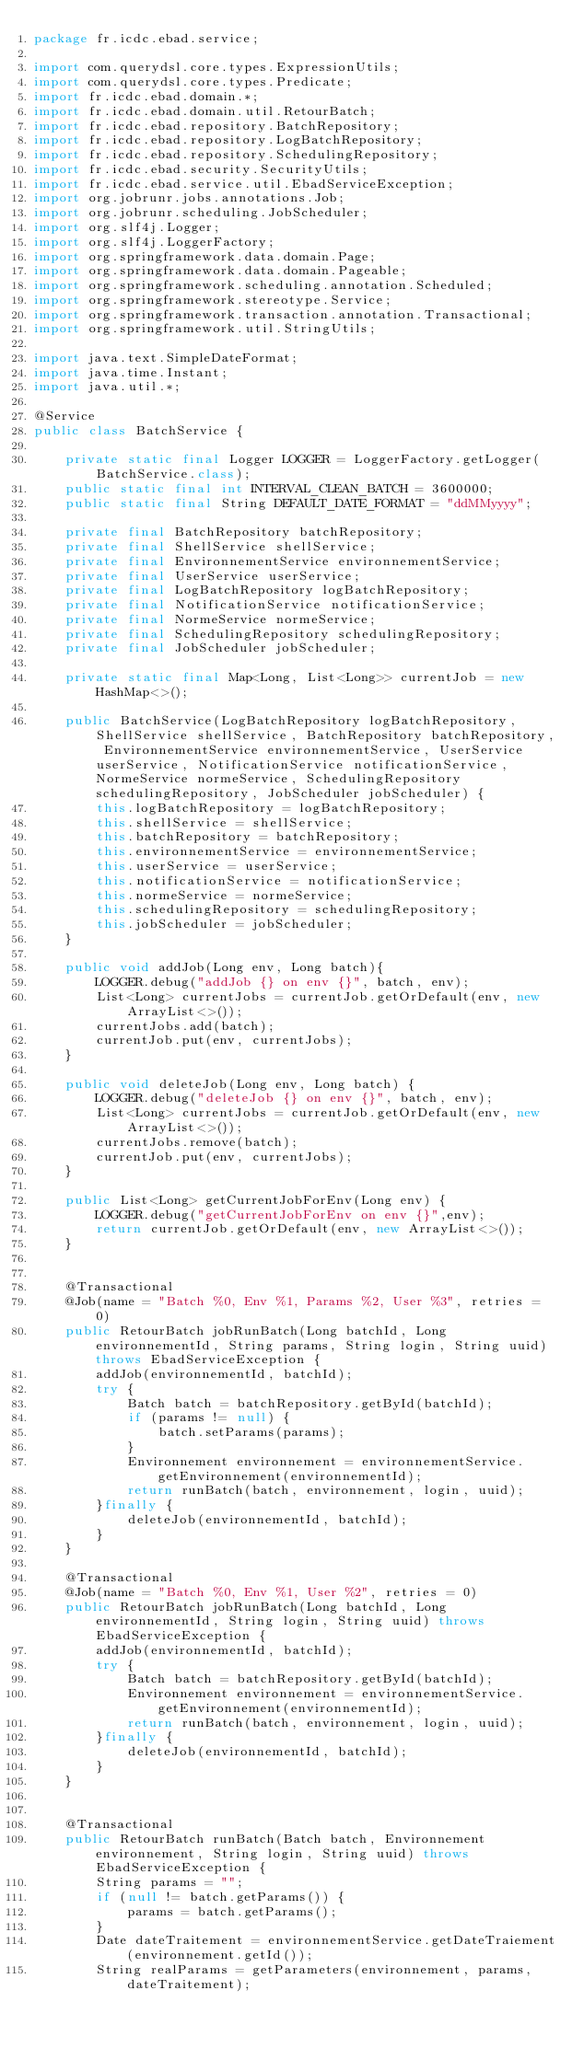Convert code to text. <code><loc_0><loc_0><loc_500><loc_500><_Java_>package fr.icdc.ebad.service;

import com.querydsl.core.types.ExpressionUtils;
import com.querydsl.core.types.Predicate;
import fr.icdc.ebad.domain.*;
import fr.icdc.ebad.domain.util.RetourBatch;
import fr.icdc.ebad.repository.BatchRepository;
import fr.icdc.ebad.repository.LogBatchRepository;
import fr.icdc.ebad.repository.SchedulingRepository;
import fr.icdc.ebad.security.SecurityUtils;
import fr.icdc.ebad.service.util.EbadServiceException;
import org.jobrunr.jobs.annotations.Job;
import org.jobrunr.scheduling.JobScheduler;
import org.slf4j.Logger;
import org.slf4j.LoggerFactory;
import org.springframework.data.domain.Page;
import org.springframework.data.domain.Pageable;
import org.springframework.scheduling.annotation.Scheduled;
import org.springframework.stereotype.Service;
import org.springframework.transaction.annotation.Transactional;
import org.springframework.util.StringUtils;

import java.text.SimpleDateFormat;
import java.time.Instant;
import java.util.*;

@Service
public class BatchService {

    private static final Logger LOGGER = LoggerFactory.getLogger(BatchService.class);
    public static final int INTERVAL_CLEAN_BATCH = 3600000;
    public static final String DEFAULT_DATE_FORMAT = "ddMMyyyy";

    private final BatchRepository batchRepository;
    private final ShellService shellService;
    private final EnvironnementService environnementService;
    private final UserService userService;
    private final LogBatchRepository logBatchRepository;
    private final NotificationService notificationService;
    private final NormeService normeService;
    private final SchedulingRepository schedulingRepository;
    private final JobScheduler jobScheduler;

    private static final Map<Long, List<Long>> currentJob = new HashMap<>();

    public BatchService(LogBatchRepository logBatchRepository, ShellService shellService, BatchRepository batchRepository, EnvironnementService environnementService, UserService userService, NotificationService notificationService, NormeService normeService, SchedulingRepository schedulingRepository, JobScheduler jobScheduler) {
        this.logBatchRepository = logBatchRepository;
        this.shellService = shellService;
        this.batchRepository = batchRepository;
        this.environnementService = environnementService;
        this.userService = userService;
        this.notificationService = notificationService;
        this.normeService = normeService;
        this.schedulingRepository = schedulingRepository;
        this.jobScheduler = jobScheduler;
    }

    public void addJob(Long env, Long batch){
        LOGGER.debug("addJob {} on env {}", batch, env);
        List<Long> currentJobs = currentJob.getOrDefault(env, new ArrayList<>());
        currentJobs.add(batch);
        currentJob.put(env, currentJobs);
    }

    public void deleteJob(Long env, Long batch) {
        LOGGER.debug("deleteJob {} on env {}", batch, env);
        List<Long> currentJobs = currentJob.getOrDefault(env, new ArrayList<>());
        currentJobs.remove(batch);
        currentJob.put(env, currentJobs);
    }

    public List<Long> getCurrentJobForEnv(Long env) {
        LOGGER.debug("getCurrentJobForEnv on env {}",env);
        return currentJob.getOrDefault(env, new ArrayList<>());
    }


    @Transactional
    @Job(name = "Batch %0, Env %1, Params %2, User %3", retries = 0)
    public RetourBatch jobRunBatch(Long batchId, Long environnementId, String params, String login, String uuid) throws EbadServiceException {
        addJob(environnementId, batchId);
        try {
            Batch batch = batchRepository.getById(batchId);
            if (params != null) {
                batch.setParams(params);
            }
            Environnement environnement = environnementService.getEnvironnement(environnementId);
            return runBatch(batch, environnement, login, uuid);
        }finally {
            deleteJob(environnementId, batchId);
        }
    }

    @Transactional
    @Job(name = "Batch %0, Env %1, User %2", retries = 0)
    public RetourBatch jobRunBatch(Long batchId, Long environnementId, String login, String uuid) throws EbadServiceException {
        addJob(environnementId, batchId);
        try {
            Batch batch = batchRepository.getById(batchId);
            Environnement environnement = environnementService.getEnvironnement(environnementId);
            return runBatch(batch, environnement, login, uuid);
        }finally {
            deleteJob(environnementId, batchId);
        }
    }


    @Transactional
    public RetourBatch runBatch(Batch batch, Environnement environnement, String login, String uuid) throws EbadServiceException {
        String params = "";
        if (null != batch.getParams()) {
            params = batch.getParams();
        }
        Date dateTraitement = environnementService.getDateTraiement(environnement.getId());
        String realParams = getParameters(environnement, params, dateTraitement);
</code> 